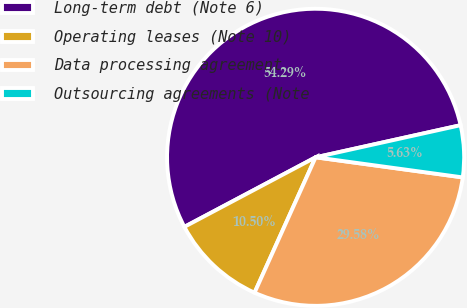Convert chart to OTSL. <chart><loc_0><loc_0><loc_500><loc_500><pie_chart><fcel>Long-term debt (Note 6)<fcel>Operating leases (Note 10)<fcel>Data processing agreement<fcel>Outsourcing agreements (Note<nl><fcel>54.29%<fcel>10.5%<fcel>29.58%<fcel>5.63%<nl></chart> 